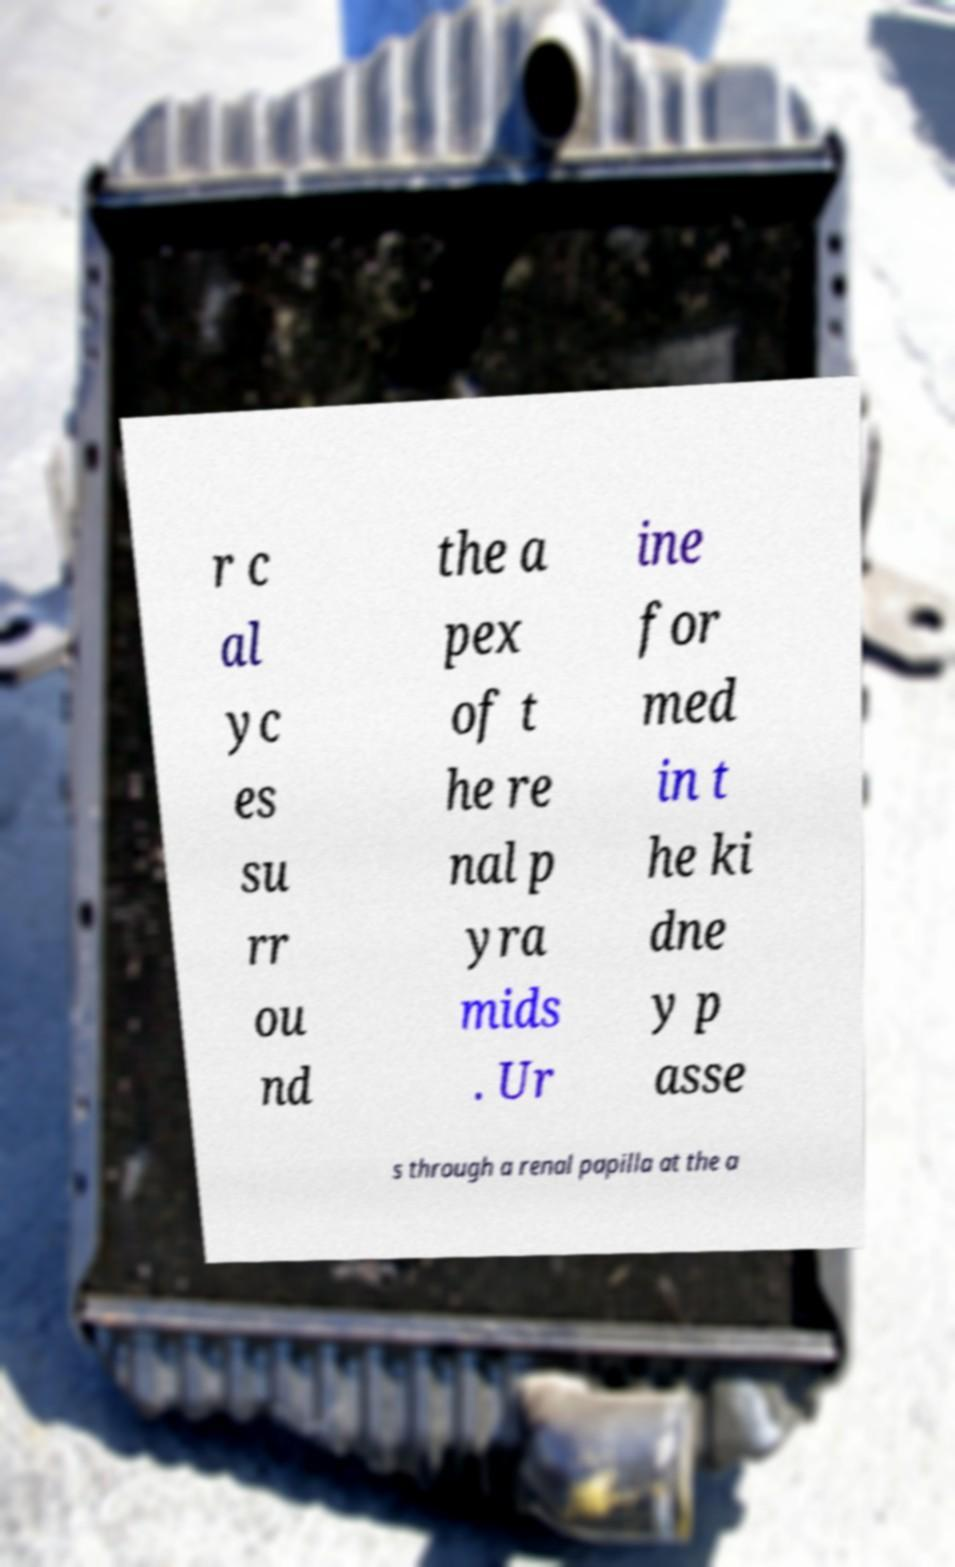Could you assist in decoding the text presented in this image and type it out clearly? r c al yc es su rr ou nd the a pex of t he re nal p yra mids . Ur ine for med in t he ki dne y p asse s through a renal papilla at the a 